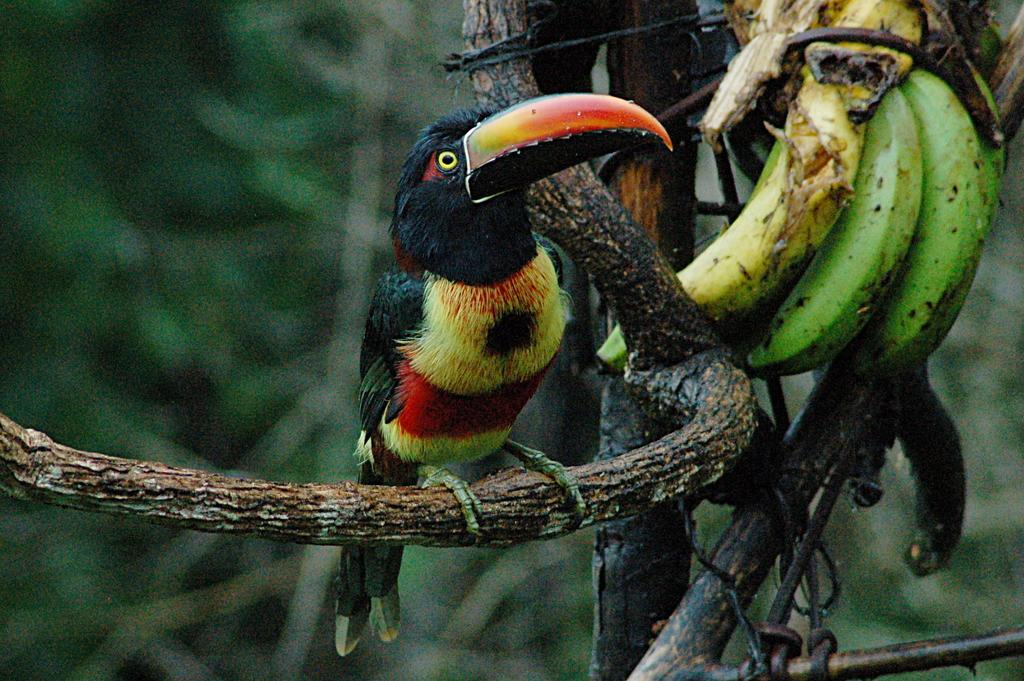What type of animal can be seen in the image? There is a bird in the image. What colors are present on the bird? The bird has black, red, and yellow colors. Where is the bird located in the image? The bird is on a branch of a tree. What is near the tree in the image? There are bananas near the tree. How would you describe the background of the image? The background of the image is blurred. What territory does the bird's grandmother rule over in the image? There is no information about the bird's grandmother or any territory in the image. 